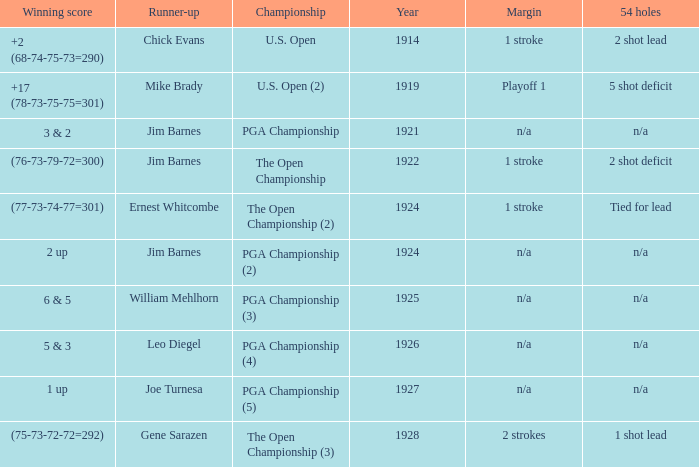WHAT WAS THE WINNING SCORE IN YEAR 1922? (76-73-79-72=300). 